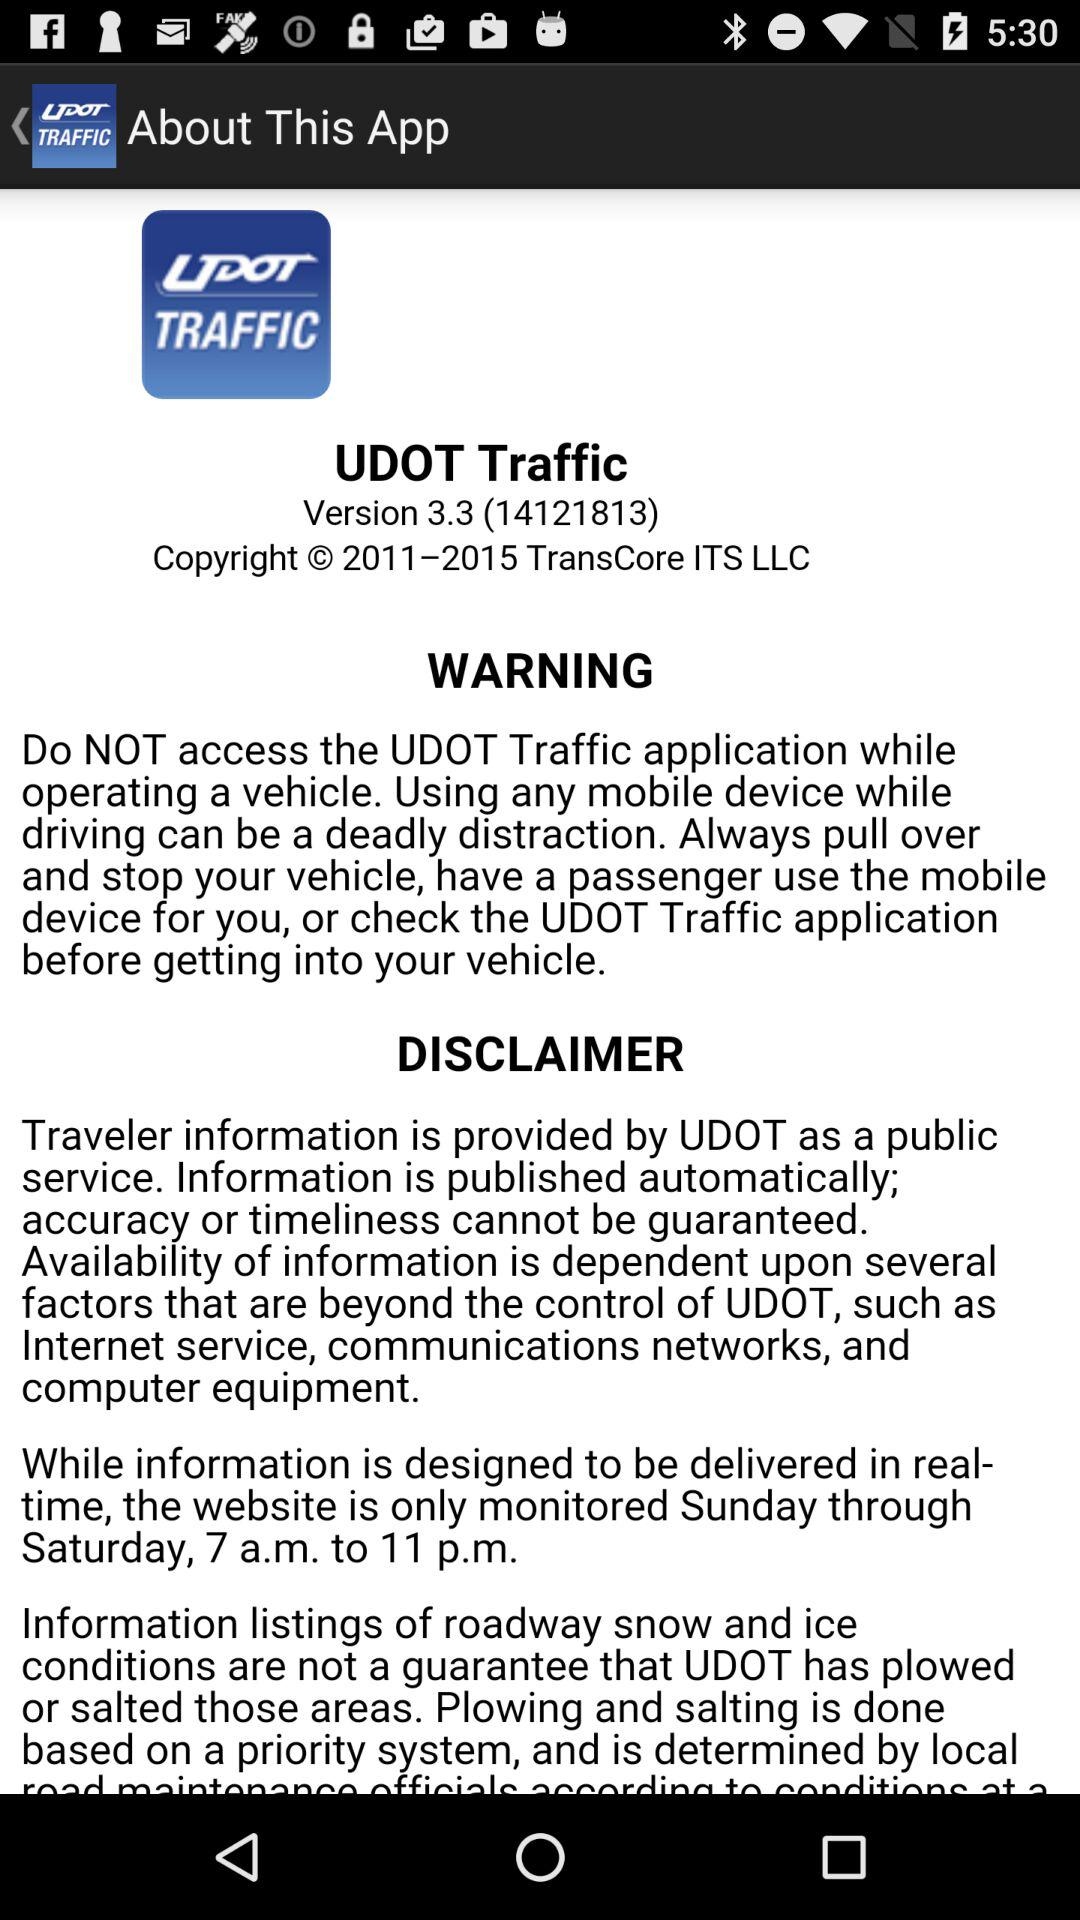What is the name of the application? The name of the application is "UDOT Traffic". 